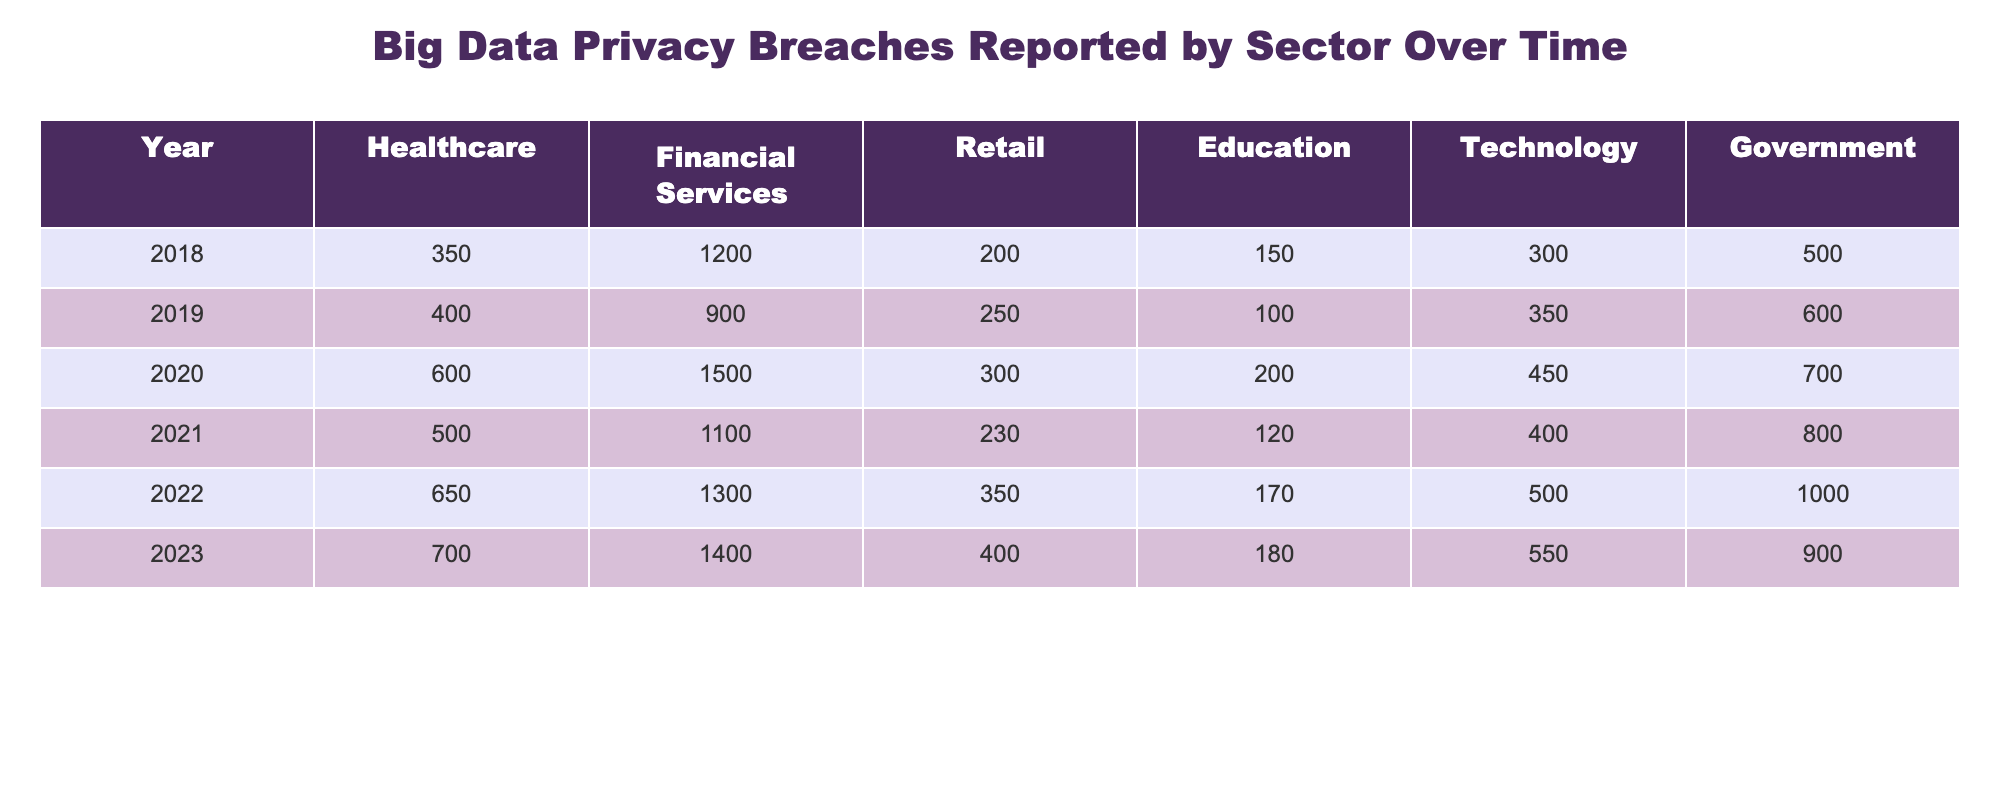What was the highest number of reported breaches in the Healthcare sector? From the table, the Healthcare sector reported 700 breaches in 2023, which is the highest value listed across all years.
Answer: 700 Which sector had the least number of breaches in 2019? In 2019, the Retail sector had the least number of breaches reported, with a total of 250.
Answer: 250 What is the average number of breaches reported in the Financial Services sector over the entire period? The Financial Services sector breaches for the years are: 1200, 900, 1500, 1100, 1300, and 1400. Summing these gives 6300, and dividing by 6 (the number of years) results in an average of 1050.
Answer: 1050 Did the number of reported breaches in the Technology sector increase from 2020 to 2021? In 2020, the Technology sector had 450 breaches, and in 2021, it had 400 breaches. Since 400 is less than 450, the number of reported breaches did not increase.
Answer: No What was the total number of breaches reported in the Government sector from 2018 to 2022? The breaches in the Government sector for those years are: 500 (2018) + 600 (2019) + 700 (2020) + 800 (2021) + 1000 (2022) = 3600.
Answer: 3600 Which sector saw the largest increase in the number of breaches from 2018 to 2023? Comparing the years, the Technology sector increased from 300 in 2018 to 550 in 2023, which is an increase of 250. The Healthcare sector also increased from 350 to 700, which is also 350. The largest increase was in the Healthcare sector.
Answer: Healthcare How many breaches were reported in the Retail sector in 2020? The Retail sector reported 300 breaches in 2020, as seen directly in the table.
Answer: 300 Which sector had a consistent increase in reported breaches from 2018 to 2023? By examining all years represented, the Government sector shows an increase each year: 500 to 600 to 700 to 800 to 1000. Hence, it had a consistent increase.
Answer: Yes How many more breaches did the Financial Services sector report in 2020 compared to 2019? The Financial Services sector reported 1500 breaches in 2020 and 900 in 2019. The difference is 1500 - 900 = 600, indicating it reported 600 more breaches in 2020.
Answer: 600 